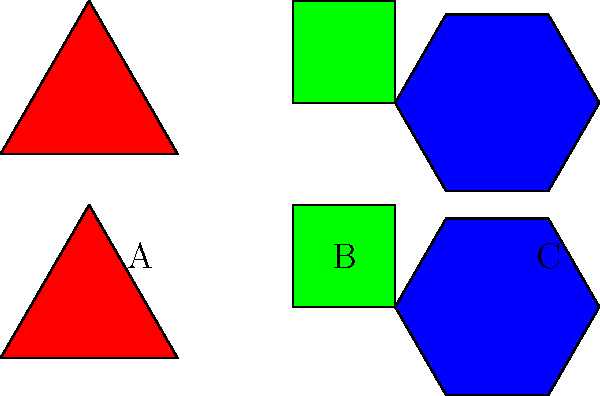In a novel with interconnected plot points represented by tessellating geometric shapes, three key narrative elements are symbolized by a triangle (A), a square (B), and a hexagon (C). If the novel contains 24 chapters, and each shape represents an equal number of chapters, how many chapters does the square (B) represent? To solve this problem, we need to follow these steps:

1. Identify the shapes: We have three shapes - triangle (A), square (B), and hexagon (C).

2. Calculate the total number of sides:
   Triangle: 3 sides
   Square: 4 sides
   Hexagon: 6 sides
   Total sides = 3 + 4 + 6 = 13

3. Set up a proportion:
   Let x be the number of chapters represented by each side.
   Total chapters = 13x = 24

4. Solve for x:
   13x = 24
   x = 24 ÷ 13 ≈ 1.846 chapters per side

5. Calculate chapters represented by the square:
   Square has 4 sides, so:
   Chapters represented by square = 4 * 1.846 ≈ 7.384

6. Round to the nearest whole number:
   7.384 rounds to 8 chapters

Therefore, the square (B) represents 8 chapters in the novel.
Answer: 8 chapters 